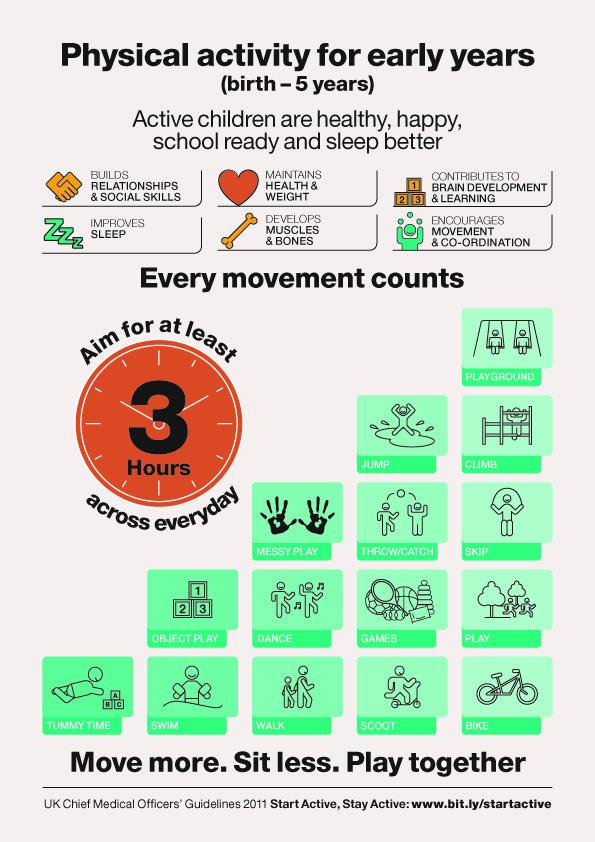Draw attention to some important aspects in this diagram. The infographic features two children walking. The infographic depicts 1.. children swimming. The infographic depicts two children dancing. 